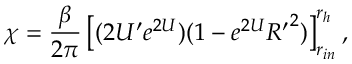<formula> <loc_0><loc_0><loc_500><loc_500>\chi = { \frac { \beta } { 2 \pi } } \left [ ( 2 U ^ { \prime } e ^ { 2 U } ) ( 1 - e ^ { 2 U } { R ^ { \prime } } ^ { 2 } ) \right ] _ { r _ { i n } } ^ { r _ { h } } ,</formula> 